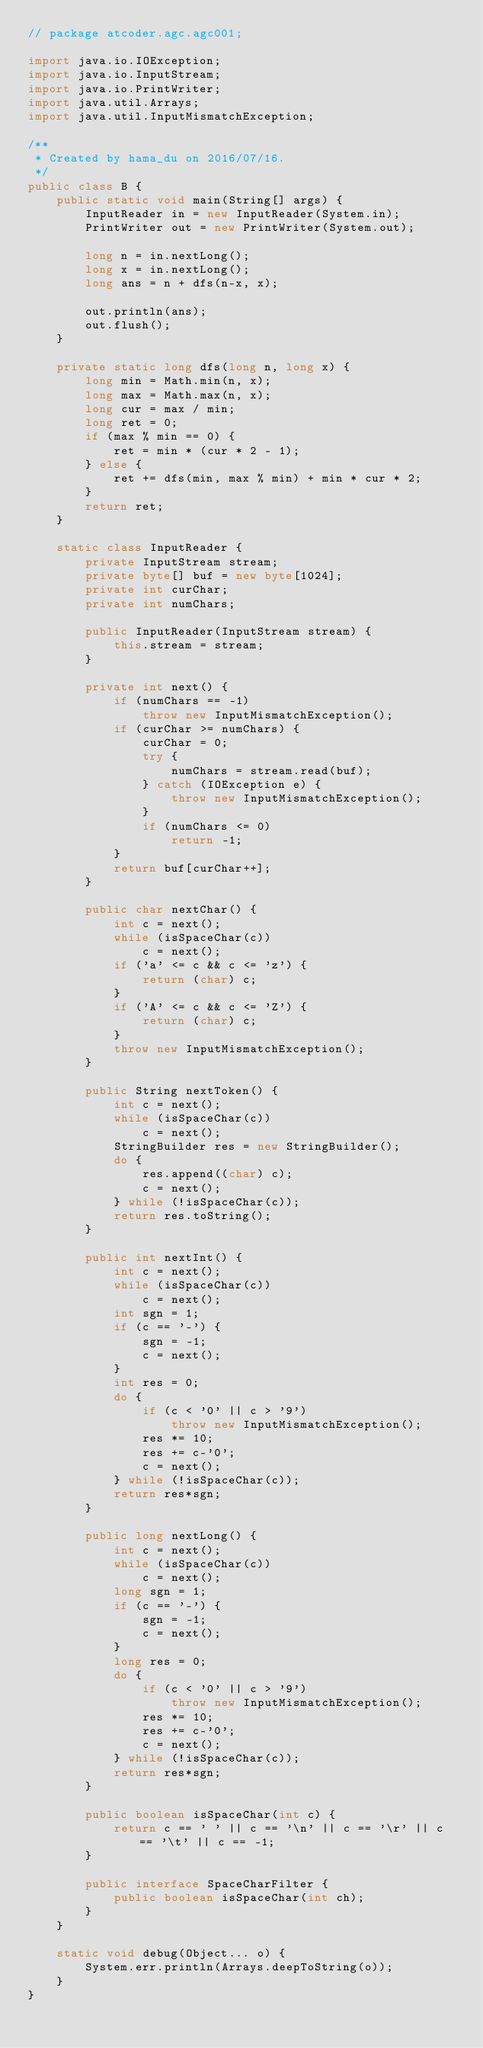<code> <loc_0><loc_0><loc_500><loc_500><_Java_>// package atcoder.agc.agc001;

import java.io.IOException;
import java.io.InputStream;
import java.io.PrintWriter;
import java.util.Arrays;
import java.util.InputMismatchException;

/**
 * Created by hama_du on 2016/07/16.
 */
public class B {
    public static void main(String[] args) {
        InputReader in = new InputReader(System.in);
        PrintWriter out = new PrintWriter(System.out);

        long n = in.nextLong();
        long x = in.nextLong();
        long ans = n + dfs(n-x, x);

        out.println(ans);
        out.flush();
    }

    private static long dfs(long n, long x) {
        long min = Math.min(n, x);
        long max = Math.max(n, x);
        long cur = max / min;
        long ret = 0;
        if (max % min == 0) {
            ret = min * (cur * 2 - 1);
        } else {
            ret += dfs(min, max % min) + min * cur * 2;
        }
        return ret;
    }

    static class InputReader {
        private InputStream stream;
        private byte[] buf = new byte[1024];
        private int curChar;
        private int numChars;

        public InputReader(InputStream stream) {
            this.stream = stream;
        }

        private int next() {
            if (numChars == -1)
                throw new InputMismatchException();
            if (curChar >= numChars) {
                curChar = 0;
                try {
                    numChars = stream.read(buf);
                } catch (IOException e) {
                    throw new InputMismatchException();
                }
                if (numChars <= 0)
                    return -1;
            }
            return buf[curChar++];
        }

        public char nextChar() {
            int c = next();
            while (isSpaceChar(c))
                c = next();
            if ('a' <= c && c <= 'z') {
                return (char) c;
            }
            if ('A' <= c && c <= 'Z') {
                return (char) c;
            }
            throw new InputMismatchException();
        }

        public String nextToken() {
            int c = next();
            while (isSpaceChar(c))
                c = next();
            StringBuilder res = new StringBuilder();
            do {
                res.append((char) c);
                c = next();
            } while (!isSpaceChar(c));
            return res.toString();
        }

        public int nextInt() {
            int c = next();
            while (isSpaceChar(c))
                c = next();
            int sgn = 1;
            if (c == '-') {
                sgn = -1;
                c = next();
            }
            int res = 0;
            do {
                if (c < '0' || c > '9')
                    throw new InputMismatchException();
                res *= 10;
                res += c-'0';
                c = next();
            } while (!isSpaceChar(c));
            return res*sgn;
        }

        public long nextLong() {
            int c = next();
            while (isSpaceChar(c))
                c = next();
            long sgn = 1;
            if (c == '-') {
                sgn = -1;
                c = next();
            }
            long res = 0;
            do {
                if (c < '0' || c > '9')
                    throw new InputMismatchException();
                res *= 10;
                res += c-'0';
                c = next();
            } while (!isSpaceChar(c));
            return res*sgn;
        }

        public boolean isSpaceChar(int c) {
            return c == ' ' || c == '\n' || c == '\r' || c == '\t' || c == -1;
        }

        public interface SpaceCharFilter {
            public boolean isSpaceChar(int ch);
        }
    }

    static void debug(Object... o) {
        System.err.println(Arrays.deepToString(o));
    }
}
</code> 